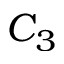Convert formula to latex. <formula><loc_0><loc_0><loc_500><loc_500>C _ { 3 }</formula> 